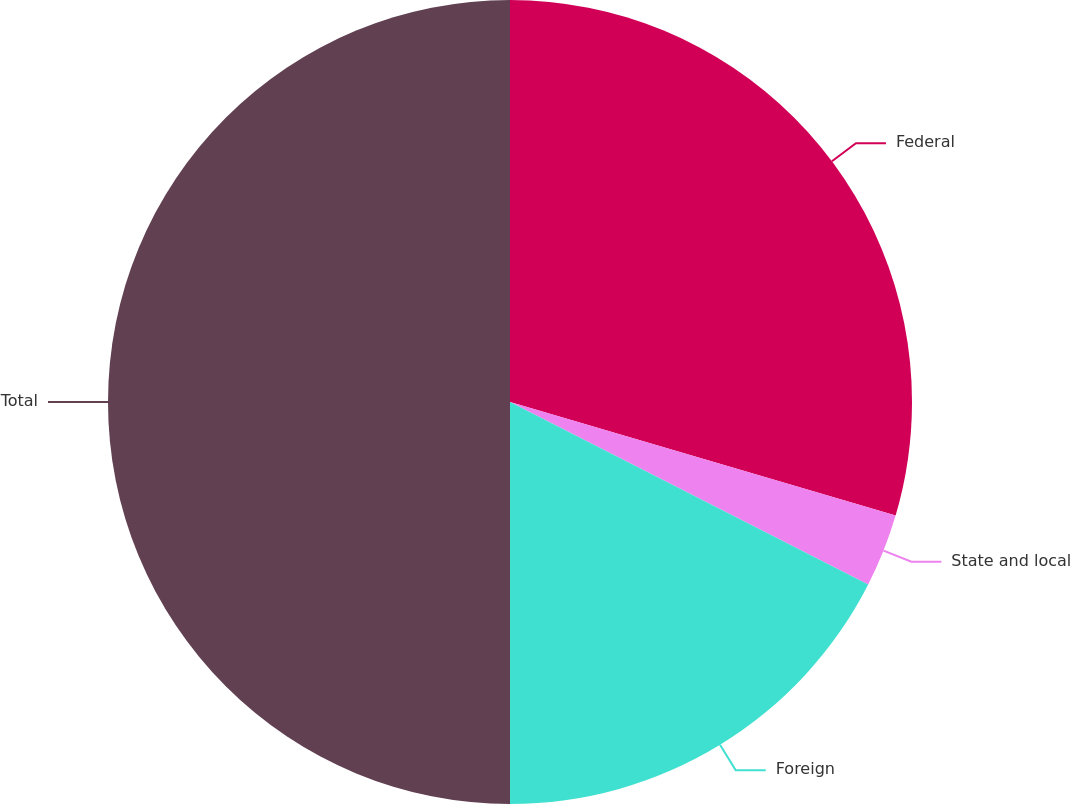<chart> <loc_0><loc_0><loc_500><loc_500><pie_chart><fcel>Federal<fcel>State and local<fcel>Foreign<fcel>Total<nl><fcel>29.56%<fcel>2.94%<fcel>17.5%<fcel>50.0%<nl></chart> 